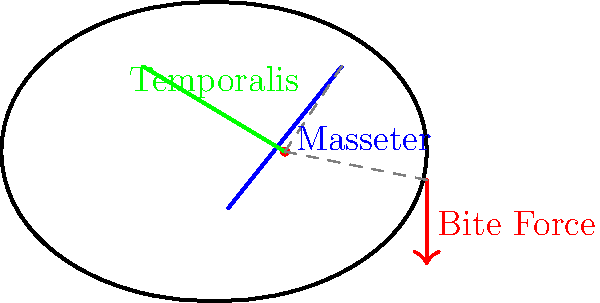In the diagram of a werewolf's skull and jaw muscles, which muscle group is likely to contribute most significantly to the bite force, and why is this relevant to the study of mythical creatures in folklore? To answer this question, let's break down the anatomy and biomechanics of the werewolf's jaw:

1. The diagram shows two main muscle groups: the Masseter and the Temporalis.

2. The Masseter muscle:
   - Runs from the cheekbone to the lower jaw
   - Has a more vertical orientation
   - Is closer to the jaw hinge (fulcrum)

3. The Temporalis muscle:
   - Runs from the side of the skull to the lower jaw
   - Has a more angled orientation
   - Is farther from the jaw hinge

4. In lever systems like the jaw, muscles closer to the fulcrum (jaw hinge) generate more force at the output (bite point).

5. The Masseter, being closer to the jaw hinge, would likely contribute more significantly to the bite force.

6. This is relevant to folklore studies because:
   - It provides a scientific approach to analyzing mythical creatures
   - It helps in understanding how storytellers might have conceived werewolf strength
   - It allows for comparison with real animals, enhancing the credibility of folklore

7. By studying the biomechanics of mythical creatures, we can:
   - Trace the origins of folklore to real-world observations
   - Understand how scientific knowledge influences mythical narratives
   - Bridge the gap between folklore and biological sciences
Answer: Masseter muscle; it provides scientific grounding for folklore analysis. 